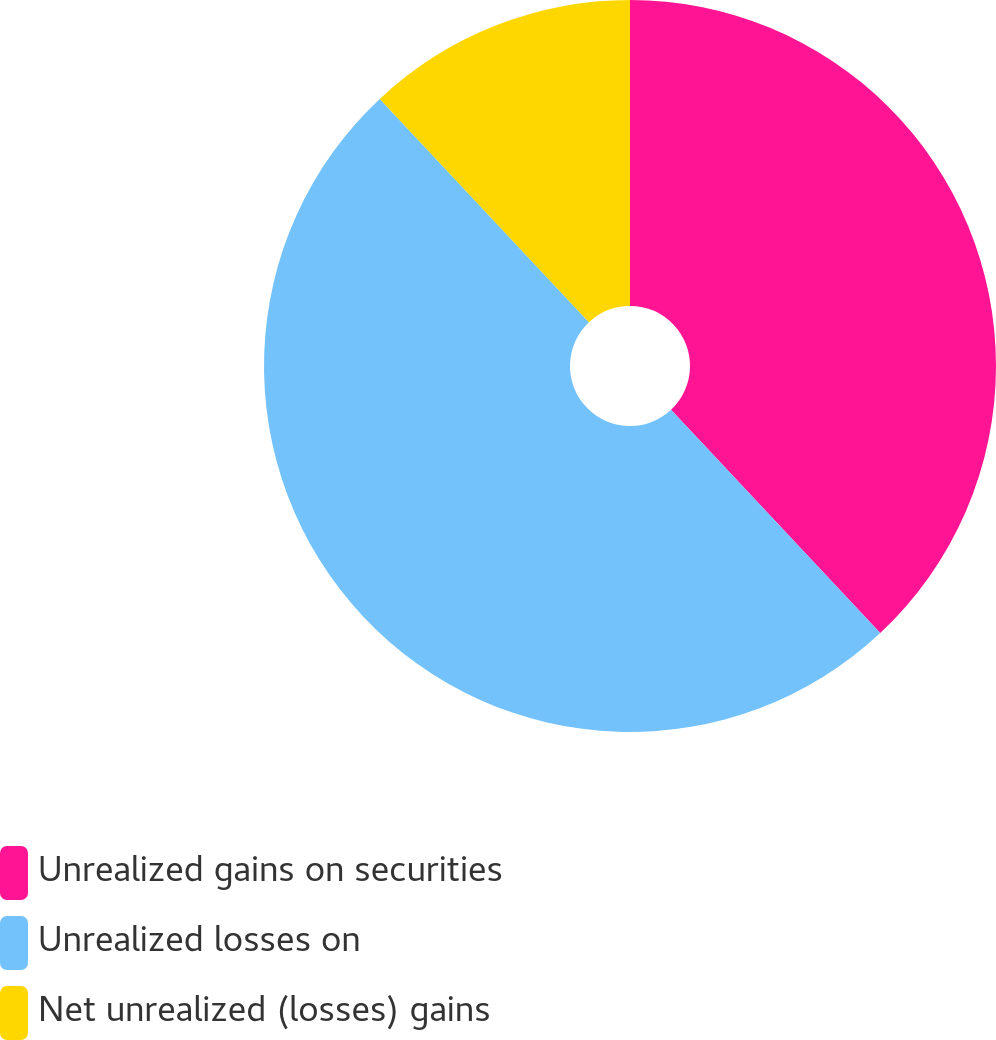<chart> <loc_0><loc_0><loc_500><loc_500><pie_chart><fcel>Unrealized gains on securities<fcel>Unrealized losses on<fcel>Net unrealized (losses) gains<nl><fcel>38.02%<fcel>50.0%<fcel>11.98%<nl></chart> 